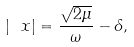Convert formula to latex. <formula><loc_0><loc_0><loc_500><loc_500>| \ x | = \frac { \sqrt { 2 \mu } } \omega - \delta ,</formula> 